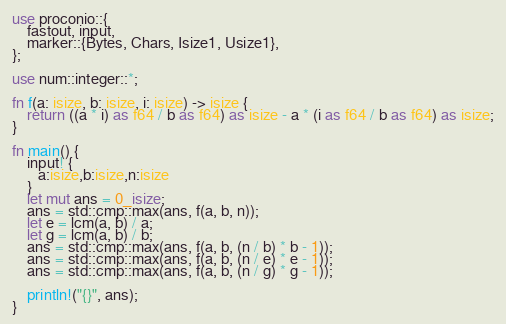Convert code to text. <code><loc_0><loc_0><loc_500><loc_500><_Rust_>use proconio::{
    fastout, input,
    marker::{Bytes, Chars, Isize1, Usize1},
};

use num::integer::*;

fn f(a: isize, b: isize, i: isize) -> isize {
    return ((a * i) as f64 / b as f64) as isize - a * (i as f64 / b as f64) as isize;
}

fn main() {
    input! {
       a:isize,b:isize,n:isize
    }
    let mut ans = 0_isize;
    ans = std::cmp::max(ans, f(a, b, n));
    let e = lcm(a, b) / a;
    let g = lcm(a, b) / b;
    ans = std::cmp::max(ans, f(a, b, (n / b) * b - 1));
    ans = std::cmp::max(ans, f(a, b, (n / e) * e - 1));
    ans = std::cmp::max(ans, f(a, b, (n / g) * g - 1));

    println!("{}", ans);
}
</code> 